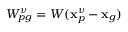Convert formula to latex. <formula><loc_0><loc_0><loc_500><loc_500>W _ { p g } ^ { \nu } = W ( x _ { p } ^ { \nu } - x _ { g } )</formula> 